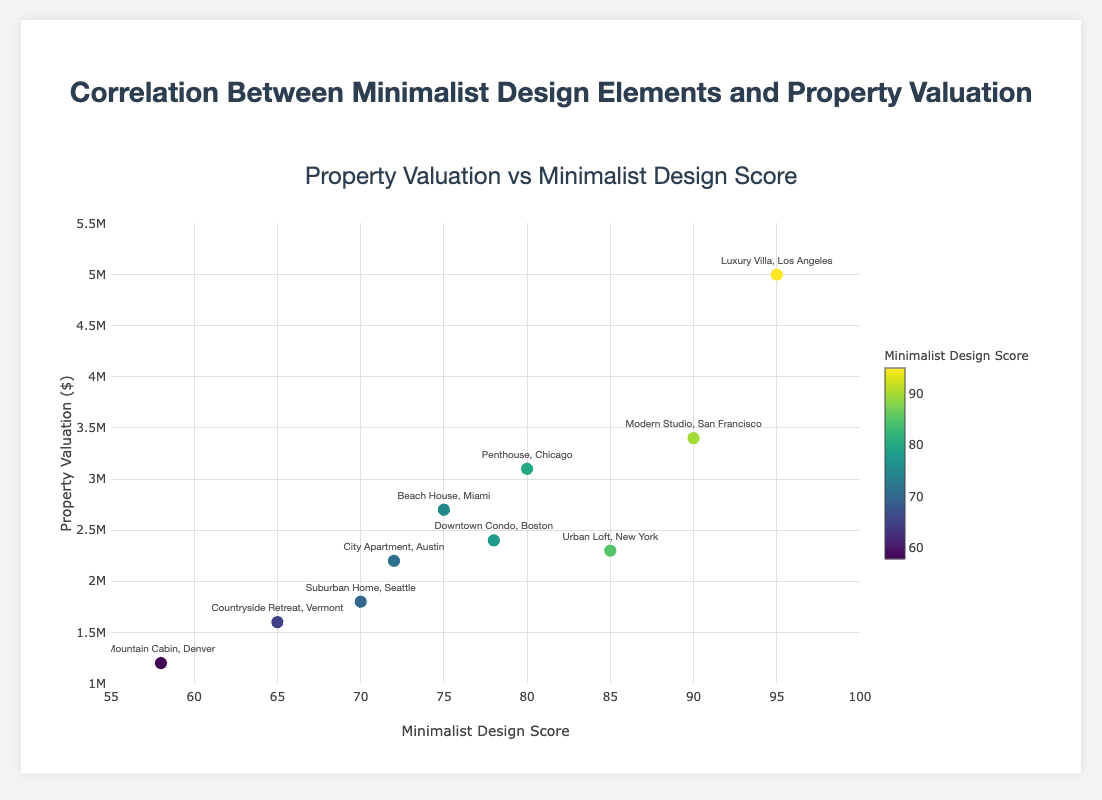What's the title of the scatter plot? The title is prominently displayed at the top of the plot. It reads, "Property Valuation vs Minimalist Design Score".
Answer: Property Valuation vs Minimalist Design Score What is the range of the x-axis? The x-axis range is shown at the bottom of the graph, below the horizontal axis line. It spans from 55 to 100.
Answer: 55 to 100 Which property has the highest minimalist design score? By examining the scatter plot, we look for the data point furthest to the right along the x-axis. The value is 95, and this corresponds to the "Luxury Villa, Los Angeles".
Answer: Luxury Villa, Los Angeles How many properties have a minimalist design score above 80? By looking at the x-axis and counting the markers positioned at x values greater than 80, we find four properties: "Urban Loft, New York", "Modern Studio, San Francisco", "Penthouse, Chicago", and "Luxury Villa, Los Angeles".
Answer: 4 What's the property valuation of the "Beach House, Miami"? Locate the "Beach House, Miami" label next to its marker. The corresponding y-value, or property valuation, is 2700000.
Answer: 2700000 Which property has the lowest property valuation? To identify the lowest y-value marker, look to the bottom-most point on the scatter plot, which corresponds to "Mountain Cabin, Denver" with a valuation of 1200000.
Answer: Mountain Cabin, Denver What's the average minimalist design score for properties with valuations above 3,000,000? First, identify properties with valuations above 3,000,000, which are "Modern Studio, San Francisco", "Penthouse, Chicago", and "Luxury Villa, Los Angeles". Their scores are 90, 80, and 95, respectively. Sum these scores (90 + 80 + 95 = 265) and divide by the number of properties (3), yielding an average score of 265/3 ≈ 88.3.
Answer: 88.3 Is there a general trend visible between minimalist design and property valuation? By observing the clustering of data points towards the higher end of both axes, a positive correlation is evident: higher minimalist design scores tend to align with higher property valuations.
Answer: Yes, a positive correlation is evident 